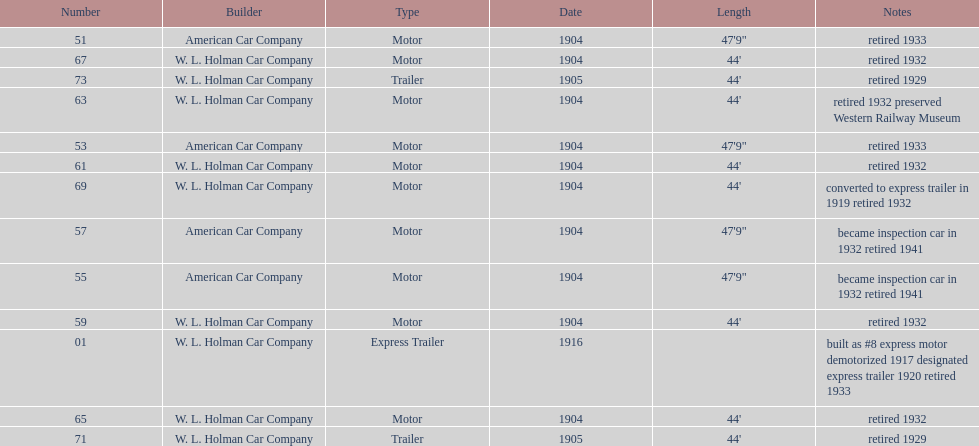How long did it take number 71 to retire? 24. 